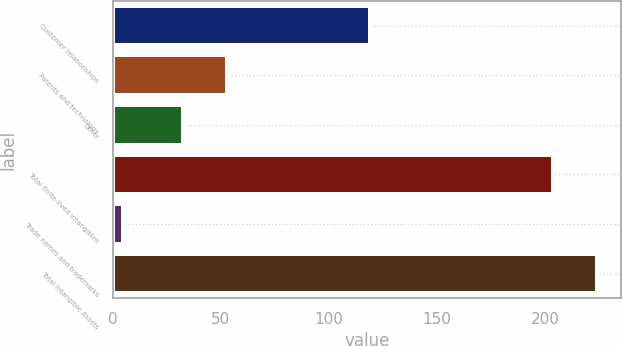<chart> <loc_0><loc_0><loc_500><loc_500><bar_chart><fcel>Customer relationships<fcel>Patents and technology<fcel>Other<fcel>Total finite-lived intangibles<fcel>Trade names and trademarks<fcel>Total Intangible Assets<nl><fcel>119<fcel>52.87<fcel>32.5<fcel>203.7<fcel>4.7<fcel>224.07<nl></chart> 